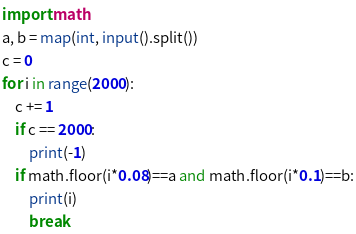<code> <loc_0><loc_0><loc_500><loc_500><_Python_>import math
a, b = map(int, input().split())
c = 0
for i in range(2000):
    c += 1
    if c == 2000:
        print(-1)
    if math.floor(i*0.08)==a and math.floor(i*0.1)==b:
        print(i)
        break </code> 